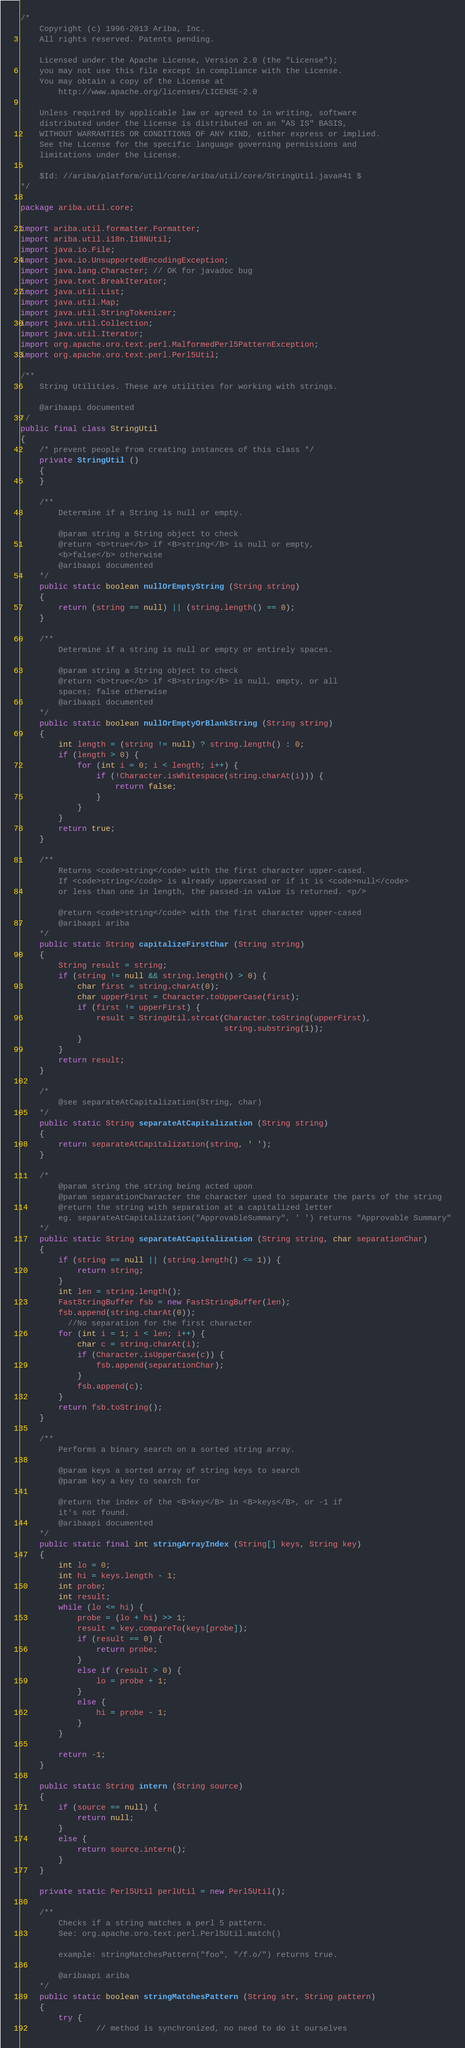Convert code to text. <code><loc_0><loc_0><loc_500><loc_500><_Java_>/*
    Copyright (c) 1996-2013 Ariba, Inc.
    All rights reserved. Patents pending.

    Licensed under the Apache License, Version 2.0 (the "License");
    you may not use this file except in compliance with the License.
    You may obtain a copy of the License at
        http://www.apache.org/licenses/LICENSE-2.0

    Unless required by applicable law or agreed to in writing, software
    distributed under the License is distributed on an "AS IS" BASIS,
    WITHOUT WARRANTIES OR CONDITIONS OF ANY KIND, either express or implied.
    See the License for the specific language governing permissions and
    limitations under the License.

    $Id: //ariba/platform/util/core/ariba/util/core/StringUtil.java#41 $
*/

package ariba.util.core;

import ariba.util.formatter.Formatter;
import ariba.util.i18n.I18NUtil;
import java.io.File;
import java.io.UnsupportedEncodingException;
import java.lang.Character; // OK for javadoc bug
import java.text.BreakIterator;
import java.util.List;
import java.util.Map;
import java.util.StringTokenizer;
import java.util.Collection;
import java.util.Iterator;
import org.apache.oro.text.perl.MalformedPerl5PatternException;
import org.apache.oro.text.perl.Perl5Util;

/**
    String Utilities. These are utilities for working with strings.

    @aribaapi documented
*/
public final class StringUtil
{
    /* prevent people from creating instances of this class */
    private StringUtil ()
    {
    }

    /**
        Determine if a String is null or empty.

        @param string a String object to check
        @return <b>true</b> if <B>string</B> is null or empty,
        <b>false</b> otherwise
        @aribaapi documented
    */
    public static boolean nullOrEmptyString (String string)
    {
        return (string == null) || (string.length() == 0);
    }

    /**
        Determine if a string is null or empty or entirely spaces.

        @param string a String object to check
        @return <b>true</b> if <B>string</B> is null, empty, or all
        spaces; false otherwise
        @aribaapi documented
    */
    public static boolean nullOrEmptyOrBlankString (String string)
    {
        int length = (string != null) ? string.length() : 0;
        if (length > 0) {
            for (int i = 0; i < length; i++) {
                if (!Character.isWhitespace(string.charAt(i))) {
                    return false;
                }
            }
        }
        return true;
    }

    /**
        Returns <code>string</code> with the first character upper-cased.
        If <code>string</code> is already uppercased or if it is <code>null</code>
        or less than one in length, the passed-in value is returned. <p/>

        @return <code>string</code> with the first character upper-cased
        @aribaapi ariba
    */
    public static String capitalizeFirstChar (String string)
    {
        String result = string;
        if (string != null && string.length() > 0) {
            char first = string.charAt(0);
            char upperFirst = Character.toUpperCase(first);
            if (first != upperFirst) {
                result = StringUtil.strcat(Character.toString(upperFirst),
                                           string.substring(1));
            }
        }
        return result;
    }

    /*
        @see separateAtCapitalization(String, char)
    */
    public static String separateAtCapitalization (String string)
    {
        return separateAtCapitalization(string, ' ');
    }

    /*
        @param string the string being acted upon
        @param separationCharacter the character used to separate the parts of the string
        @return the string with separation at a capitalized letter
        eg. separateAtCapitalization("ApprovableSummary", ' ') returns "Approvable Summary"
    */
    public static String separateAtCapitalization (String string, char separationChar)
    {
        if (string == null || (string.length() <= 1)) {
            return string;
        }
        int len = string.length();
        FastStringBuffer fsb = new FastStringBuffer(len);
        fsb.append(string.charAt(0));
          //No separation for the first character
        for (int i = 1; i < len; i++) {
            char c = string.charAt(i);
            if (Character.isUpperCase(c)) {
                fsb.append(separationChar);
            }
            fsb.append(c);
        }
        return fsb.toString();
    }

    /**
        Performs a binary search on a sorted string array.

        @param keys a sorted array of string keys to search
        @param key a key to search for

        @return the index of the <B>key</B> in <B>keys</B>, or -1 if
        it's not found.
        @aribaapi documented
    */
    public static final int stringArrayIndex (String[] keys, String key)
    {
        int lo = 0;
        int hi = keys.length - 1;
        int probe;
        int result;
        while (lo <= hi) {
            probe = (lo + hi) >> 1;
            result = key.compareTo(keys[probe]);
            if (result == 0) {
                return probe;
            }
            else if (result > 0) {
                lo = probe + 1;
            }
            else {
                hi = probe - 1;
            }
        }

        return -1;
    }

    public static String intern (String source)
    {
        if (source == null) {
            return null;
        }
        else {
            return source.intern();
        }
    }

    private static Perl5Util perlUtil = new Perl5Util();

    /**
        Checks if a string matches a perl 5 pattern.
        See: org.apache.oro.text.perl.Perl5Util.match()

        example: stringMatchesPattern("foo", "/f.o/") returns true.

        @aribaapi ariba
    */
    public static boolean stringMatchesPattern (String str, String pattern)
    {
        try {
                // method is synchronized, no need to do it ourselves</code> 